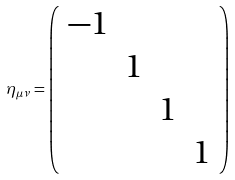Convert formula to latex. <formula><loc_0><loc_0><loc_500><loc_500>\eta _ { \mu \nu } = \left ( \begin{array} { c c c c } - 1 & & & \\ & 1 & & \\ & & 1 & \\ & & & 1 \end{array} \right )</formula> 